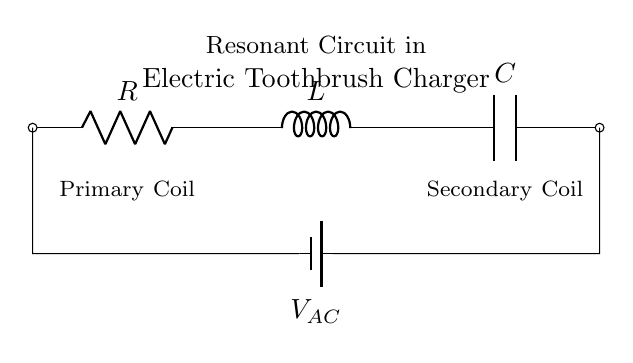what components are present in this circuit? The circuit includes a resistor, an inductor, and a capacitor. These components are labeled in the diagram.
Answer: resistor, inductor, capacitor what is the function of the resistor in this circuit? The resistor limits the current flow, providing stability and controlling power dissipation in the circuit.
Answer: limit current what does the symbol V_AC represent? V_AC indicates an alternating voltage source that powers the circuit. It provides varying voltage to create resonance in the circuit.
Answer: alternating voltage source what happens when the circuit reaches resonance? At resonance, the inductive reactance equals the capacitive reactance, maximizing the circuit's current and power transfer, which is ideal for charging.
Answer: maximized current what is the relationship between the inductor and capacitor at resonant frequency? They exhibit reciprocal behavior, where the energy oscillates between the inductor's magnetic field and the capacitor's electric field. At resonance, their reactances cancel.
Answer: reciprocal behavior 